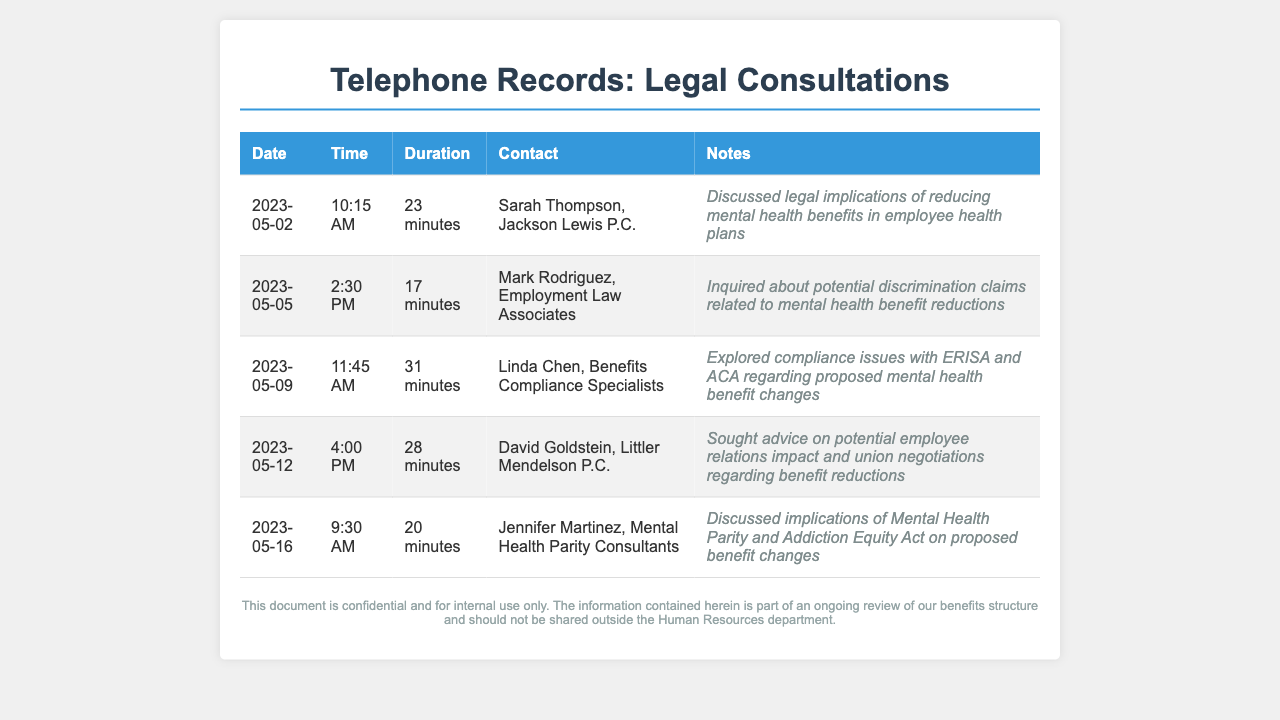What is the date of the longest call? The longest call was on May 9, lasting 31 minutes.
Answer: May 9 Who was the contact for the call about potential discrimination claims? The call about potential discrimination claims was with Mark Rodriguez.
Answer: Mark Rodriguez How many minutes did the call with Sarah Thompson last? The call with Sarah Thompson lasted 23 minutes.
Answer: 23 minutes What topic was discussed during the call with Jennifer Martinez? The topic discussed was the implications of the Mental Health Parity and Addiction Equity Act.
Answer: Mental Health Parity and Addiction Equity Act What is the name of the legal advisor specializing in benefits compliance? The legal advisor specializing in benefits compliance is Linda Chen.
Answer: Linda Chen What was the duration of the call with David Goldstein? The duration of the call with David Goldstein was 28 minutes.
Answer: 28 minutes On what date was the inquiry about potential discrimination claims made? The inquiry about potential discrimination claims was made on May 5.
Answer: May 5 Who conducted the consultation on compliance issues with ERISA and ACA? The consultation on compliance issues was conducted by Linda Chen.
Answer: Linda Chen How many calls were made in total regarding mental health benefits? A total of five calls were made regarding mental health benefits.
Answer: Five calls 